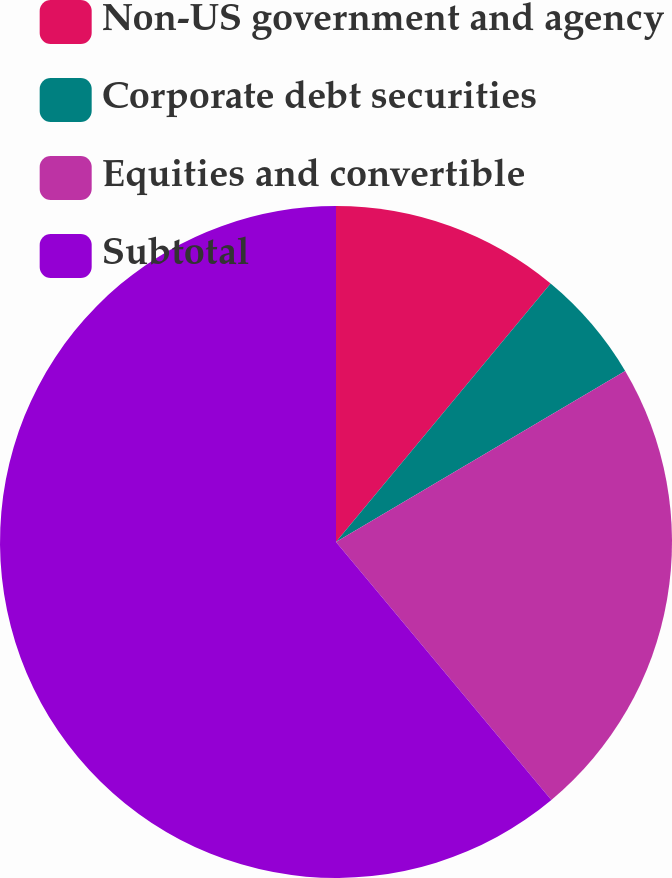<chart> <loc_0><loc_0><loc_500><loc_500><pie_chart><fcel>Non-US government and agency<fcel>Corporate debt securities<fcel>Equities and convertible<fcel>Subtotal<nl><fcel>11.03%<fcel>5.47%<fcel>22.43%<fcel>61.08%<nl></chart> 